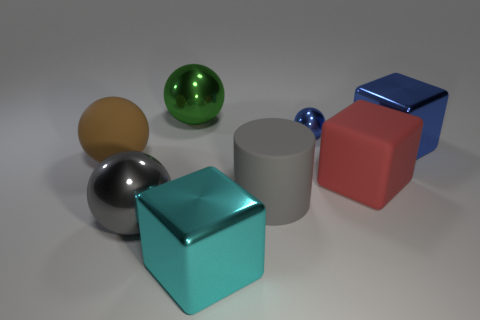Can you tell me what the different objects are made of? The objects in the image appear to be 3D renderings, and they resemble materials such as polished metal for the reflective spheres and cube, matte plastic for the non-reflective cube and cylinder, and perhaps a rubber-like material for the matte sphere. 